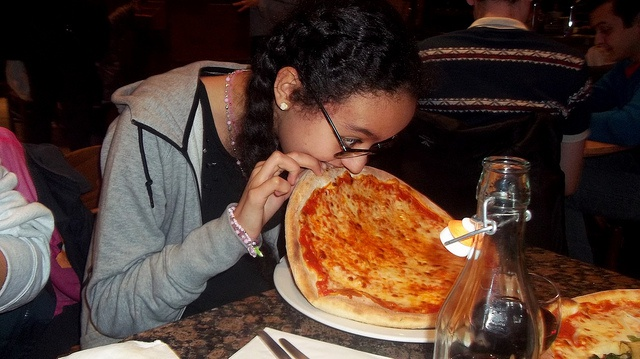Describe the objects in this image and their specific colors. I can see people in black, gray, and brown tones, pizza in black, red, tan, and brown tones, people in black, maroon, and gray tones, people in black, maroon, and brown tones, and bottle in black, brown, maroon, and gray tones in this image. 